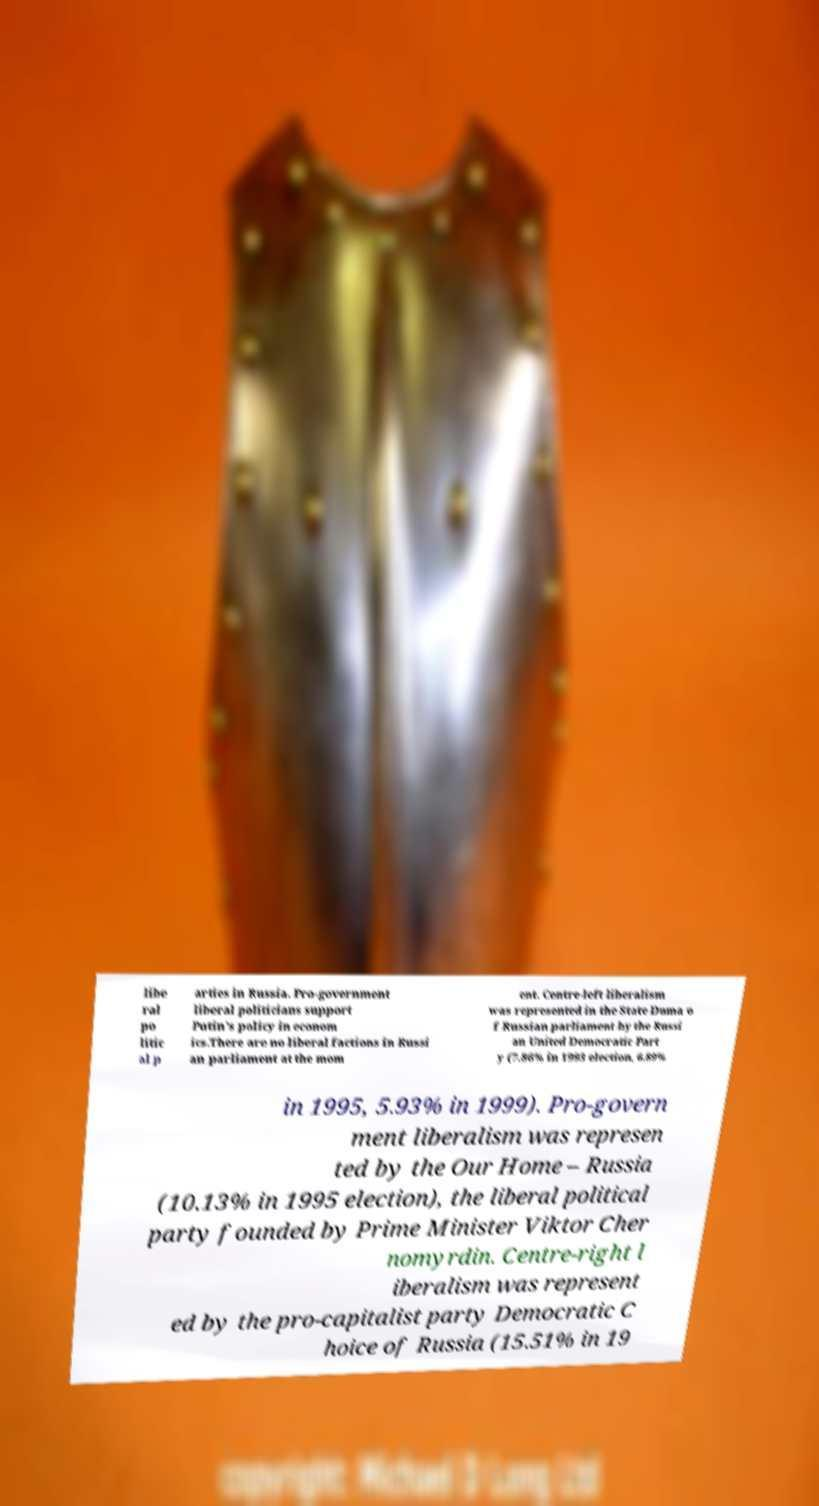Can you read and provide the text displayed in the image?This photo seems to have some interesting text. Can you extract and type it out for me? libe ral po litic al p arties in Russia. Pro-government liberal politicians support Putin's policy in econom ics.There are no liberal factions in Russi an parliament at the mom ent. Centre-left liberalism was represented in the State Duma o f Russian parliament by the Russi an United Democratic Part y (7.86% in 1993 election, 6.89% in 1995, 5.93% in 1999). Pro-govern ment liberalism was represen ted by the Our Home – Russia (10.13% in 1995 election), the liberal political party founded by Prime Minister Viktor Cher nomyrdin. Centre-right l iberalism was represent ed by the pro-capitalist party Democratic C hoice of Russia (15.51% in 19 